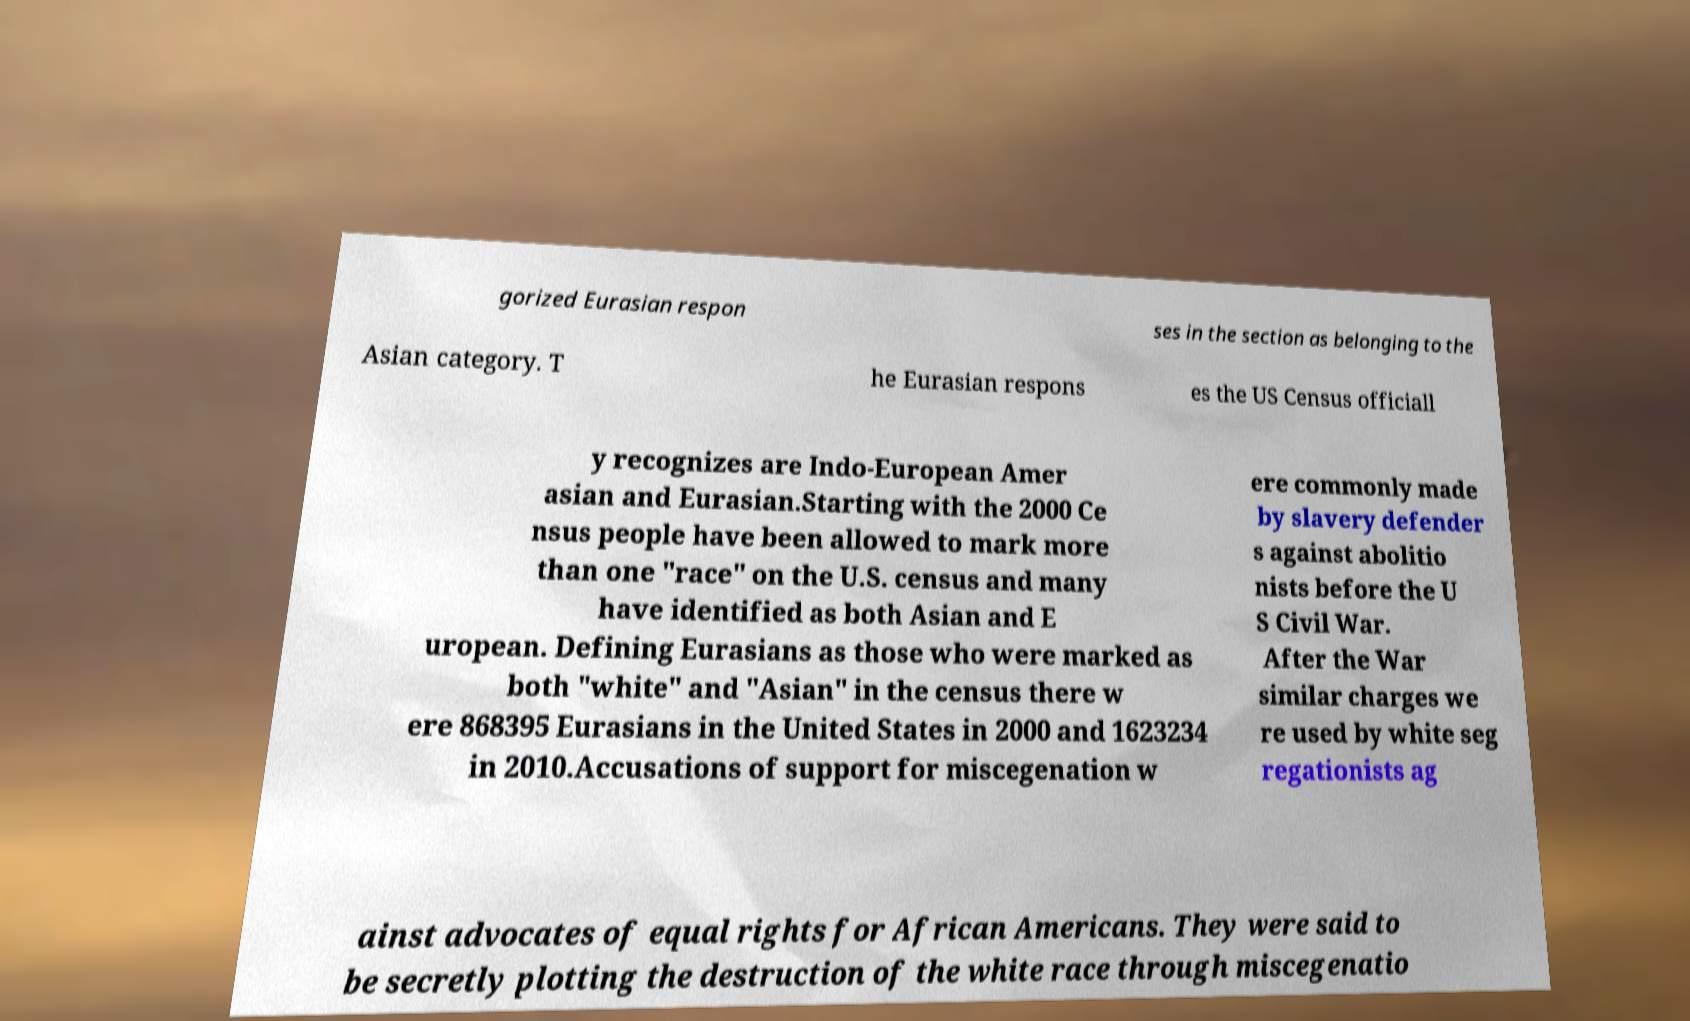Please read and relay the text visible in this image. What does it say? gorized Eurasian respon ses in the section as belonging to the Asian category. T he Eurasian respons es the US Census officiall y recognizes are Indo-European Amer asian and Eurasian.Starting with the 2000 Ce nsus people have been allowed to mark more than one "race" on the U.S. census and many have identified as both Asian and E uropean. Defining Eurasians as those who were marked as both "white" and "Asian" in the census there w ere 868395 Eurasians in the United States in 2000 and 1623234 in 2010.Accusations of support for miscegenation w ere commonly made by slavery defender s against abolitio nists before the U S Civil War. After the War similar charges we re used by white seg regationists ag ainst advocates of equal rights for African Americans. They were said to be secretly plotting the destruction of the white race through miscegenatio 